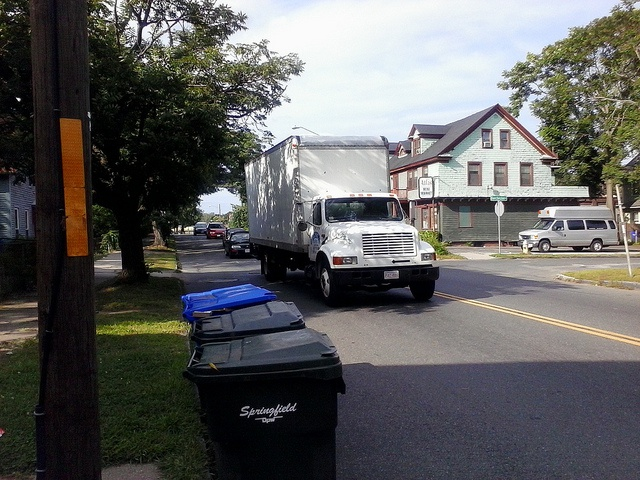Describe the objects in this image and their specific colors. I can see truck in black, lightgray, gray, and darkgray tones, car in black, darkgray, lightgray, and gray tones, car in black, gray, and darkgray tones, car in black, gray, maroon, and darkgray tones, and stop sign in black, lightgray, gray, and darkgray tones in this image. 